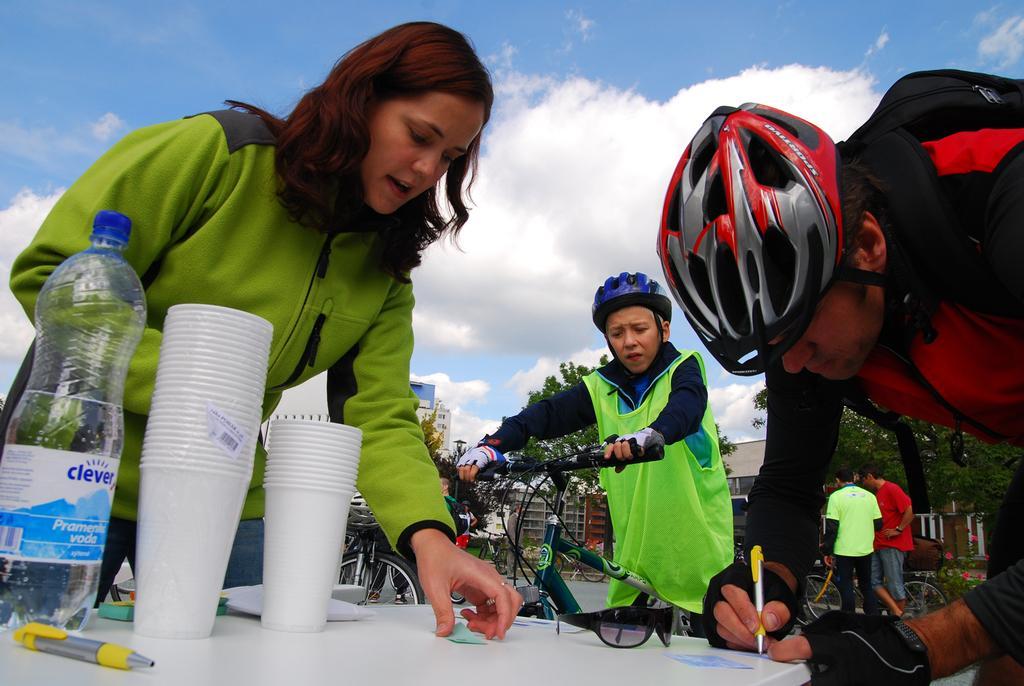Describe this image in one or two sentences. In this image on the right side there is one man who is writing. On the left side there is one woman who is talking and in the center there is one boy who is sitting on a cycle and in the bottom of the right corner there are two persons who are standing and in the background there is a sky, and in the middle there are some buildings and trees are there and on the table there are cups and bottle and one pen is there. 